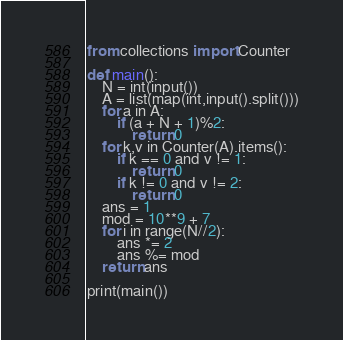Convert code to text. <code><loc_0><loc_0><loc_500><loc_500><_Python_>from collections import Counter

def main():
    N = int(input())
    A = list(map(int,input().split()))
    for a in A:
        if (a + N + 1)%2:
            return 0
    for k,v in Counter(A).items():
        if k == 0 and v != 1:
            return 0
        if k != 0 and v != 2:
            return 0
    ans = 1
    mod = 10**9 + 7
    for i in range(N//2):
        ans *= 2
        ans %= mod
    return ans

print(main())

</code> 